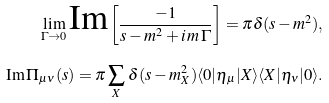<formula> <loc_0><loc_0><loc_500><loc_500>\lim _ { \Gamma \rightarrow 0 } \text {Im} \left [ \frac { - 1 } { s - m ^ { 2 } + i \, m \, \Gamma } \right ] = \pi \delta ( s - m ^ { 2 } ) , \\ \text {Im} \, \Pi _ { \mu \nu } ( s ) = \pi \sum _ { X } \, \delta ( s - m _ { X } ^ { 2 } ) \langle 0 | \eta _ { \mu } | X \rangle \langle X | \eta _ { \nu } | 0 \rangle .</formula> 